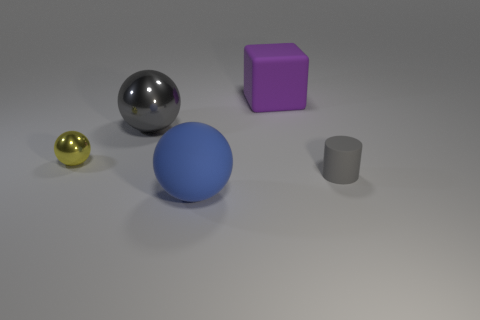Subtract all big spheres. How many spheres are left? 1 Add 5 big gray rubber balls. How many objects exist? 10 Subtract all balls. How many objects are left? 2 Subtract all green cylinders. Subtract all green balls. How many cylinders are left? 1 Subtract all green cylinders. How many red blocks are left? 0 Subtract all big balls. Subtract all matte balls. How many objects are left? 2 Add 4 big blue balls. How many big blue balls are left? 5 Add 2 purple matte cubes. How many purple matte cubes exist? 3 Subtract all gray balls. How many balls are left? 2 Subtract 0 gray cubes. How many objects are left? 5 